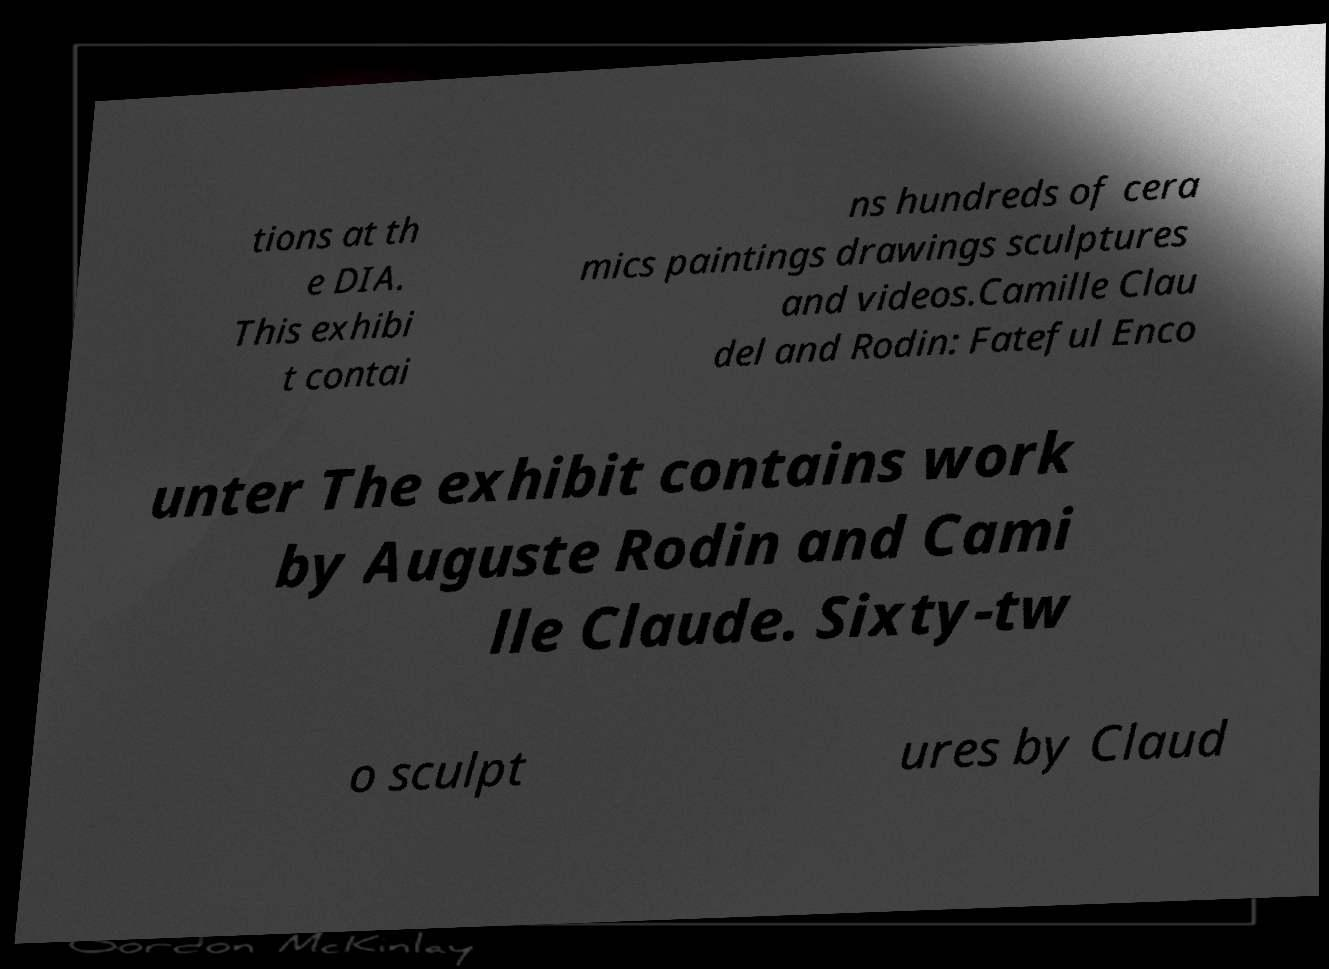I need the written content from this picture converted into text. Can you do that? tions at th e DIA. This exhibi t contai ns hundreds of cera mics paintings drawings sculptures and videos.Camille Clau del and Rodin: Fateful Enco unter The exhibit contains work by Auguste Rodin and Cami lle Claude. Sixty-tw o sculpt ures by Claud 